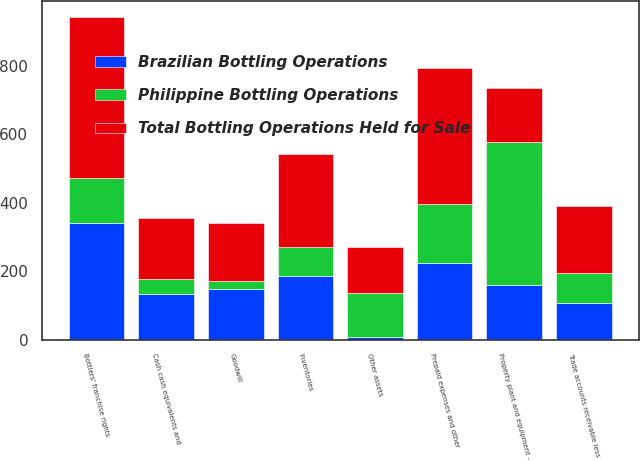Convert chart. <chart><loc_0><loc_0><loc_500><loc_500><stacked_bar_chart><ecel><fcel>Cash cash equivalents and<fcel>Trade accounts receivable less<fcel>Inventories<fcel>Prepaid expenses and other<fcel>Other assets<fcel>Property plant and equipment -<fcel>Bottlers' franchise rights<fcel>Goodwill<nl><fcel>Brazilian Bottling Operations<fcel>133<fcel>108<fcel>187<fcel>223<fcel>7<fcel>159<fcel>341<fcel>148<nl><fcel>Philippine Bottling Operations<fcel>45<fcel>88<fcel>85<fcel>174<fcel>128<fcel>419<fcel>130<fcel>22<nl><fcel>Total Bottling Operations Held for Sale<fcel>178<fcel>196<fcel>272<fcel>397<fcel>135<fcel>159<fcel>471<fcel>170<nl></chart> 